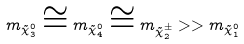Convert formula to latex. <formula><loc_0><loc_0><loc_500><loc_500>m _ { \tilde { \chi } ^ { 0 } _ { 3 } } \cong m _ { \tilde { \chi } ^ { 0 } _ { 4 } } \cong m _ { \tilde { \chi } ^ { \pm } _ { 2 } } > > m _ { \tilde { \chi } ^ { 0 } _ { 1 } }</formula> 